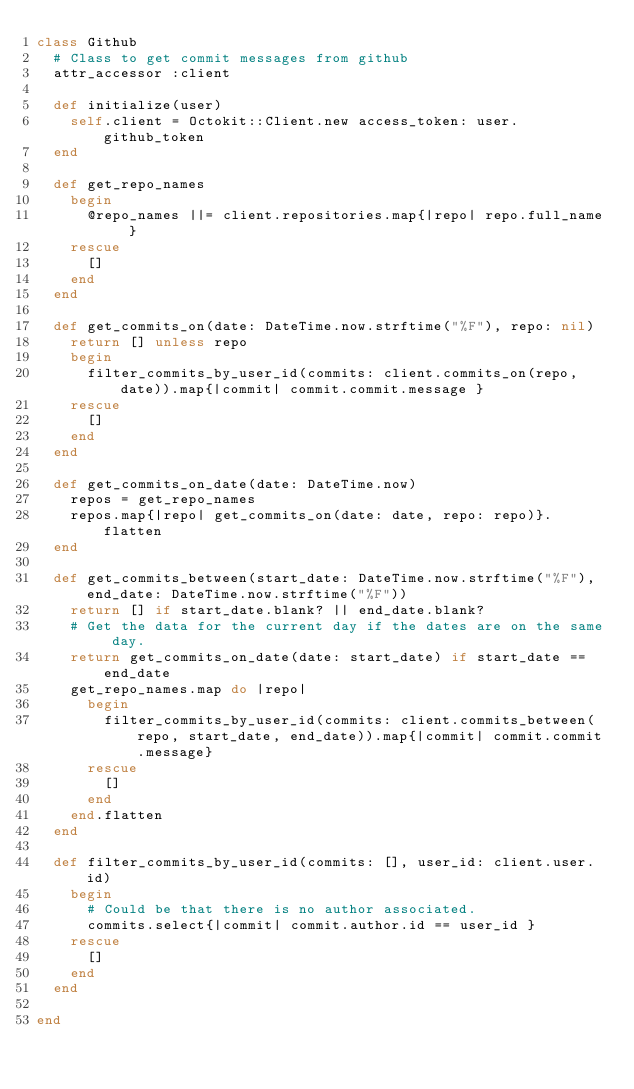<code> <loc_0><loc_0><loc_500><loc_500><_Ruby_>class Github
  # Class to get commit messages from github
  attr_accessor :client

  def initialize(user)
    self.client = Octokit::Client.new access_token: user.github_token
  end

  def get_repo_names
    begin
      @repo_names ||= client.repositories.map{|repo| repo.full_name }
    rescue
      []
    end
  end

  def get_commits_on(date: DateTime.now.strftime("%F"), repo: nil)
    return [] unless repo
    begin
      filter_commits_by_user_id(commits: client.commits_on(repo, date)).map{|commit| commit.commit.message }
    rescue
      []
    end
  end

  def get_commits_on_date(date: DateTime.now)
    repos = get_repo_names
    repos.map{|repo| get_commits_on(date: date, repo: repo)}.flatten
  end

  def get_commits_between(start_date: DateTime.now.strftime("%F"), end_date: DateTime.now.strftime("%F"))
    return [] if start_date.blank? || end_date.blank?
    # Get the data for the current day if the dates are on the same day.
    return get_commits_on_date(date: start_date) if start_date == end_date
    get_repo_names.map do |repo|
      begin
        filter_commits_by_user_id(commits: client.commits_between(repo, start_date, end_date)).map{|commit| commit.commit.message}
      rescue
        []
      end
    end.flatten
  end

  def filter_commits_by_user_id(commits: [], user_id: client.user.id)
    begin
      # Could be that there is no author associated.
      commits.select{|commit| commit.author.id == user_id }
    rescue
      []
    end
  end

end
</code> 